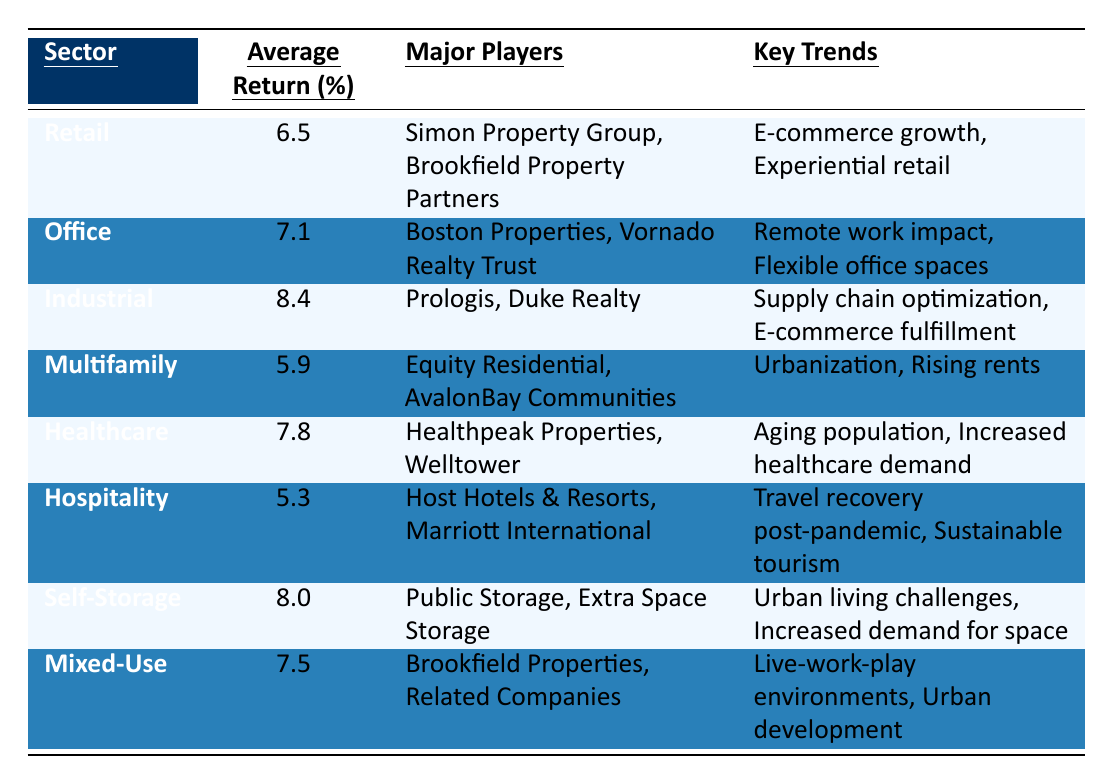What is the average return for the Industrial sector? The table shows that the average return for the Industrial sector is 8.4%.
Answer: 8.4% Which sector has the highest average return? By comparing the average returns listed, the Industrial sector has the highest average return of 8.4%.
Answer: Industrial What are the major players in the Healthcare sector? The table indicates that the major players in the Healthcare sector are Healthpeak Properties and Welltower.
Answer: Healthpeak Properties, Welltower Is the average return for Hospitality higher than for Multifamily? The average return for Hospitality is 5.3% and for Multifamily it is 5.9%. Since 5.3% is less than 5.9%, the average return for Hospitality is not higher than Multifamily.
Answer: No What is the key trend for the Self-Storage sector? The table states that the key trends for Self-Storage are urban living challenges and increased demand for space.
Answer: Urban living challenges, increased demand for space If you were to average the returns of the Retail and Hospitality sectors, what would that return be? The average return for Retail is 6.5% and for Hospitality is 5.3%. Adding them gives 6.5 + 5.3 = 11.8%. Dividing that by 2 gives 11.8/2 = 5.9%.
Answer: 5.9% Which sector has a return closest to the average return of the Office sector? The average return for the Office sector is 7.1%, looking through the other sectors, Mixed-Use has an average return of 7.5%, which is the closest.
Answer: Mixed-Use Are there any sectors with an average return below 6%? Checking the table, Multifamily (5.9%) and Hospitality (5.3%) both have average returns below 6%. Therefore, there are sectors below this threshold.
Answer: Yes What percentage difference exists between the average returns of Healthcare and Industrial sectors? The Healthcare average return is 7.8% and the Industrial average return is 8.4%. The difference is 8.4 - 7.8 = 0.6%. To find the percentage difference, divide 0.6 by 7.8 and multiply by 100, which gives approximately 7.69%.
Answer: Approximately 7.69% What factors are influencing the Retail sector according to the key trends? The table lists two key trends affecting the Retail sector: e-commerce growth and experiential retail.
Answer: E-commerce growth, experiential retail 